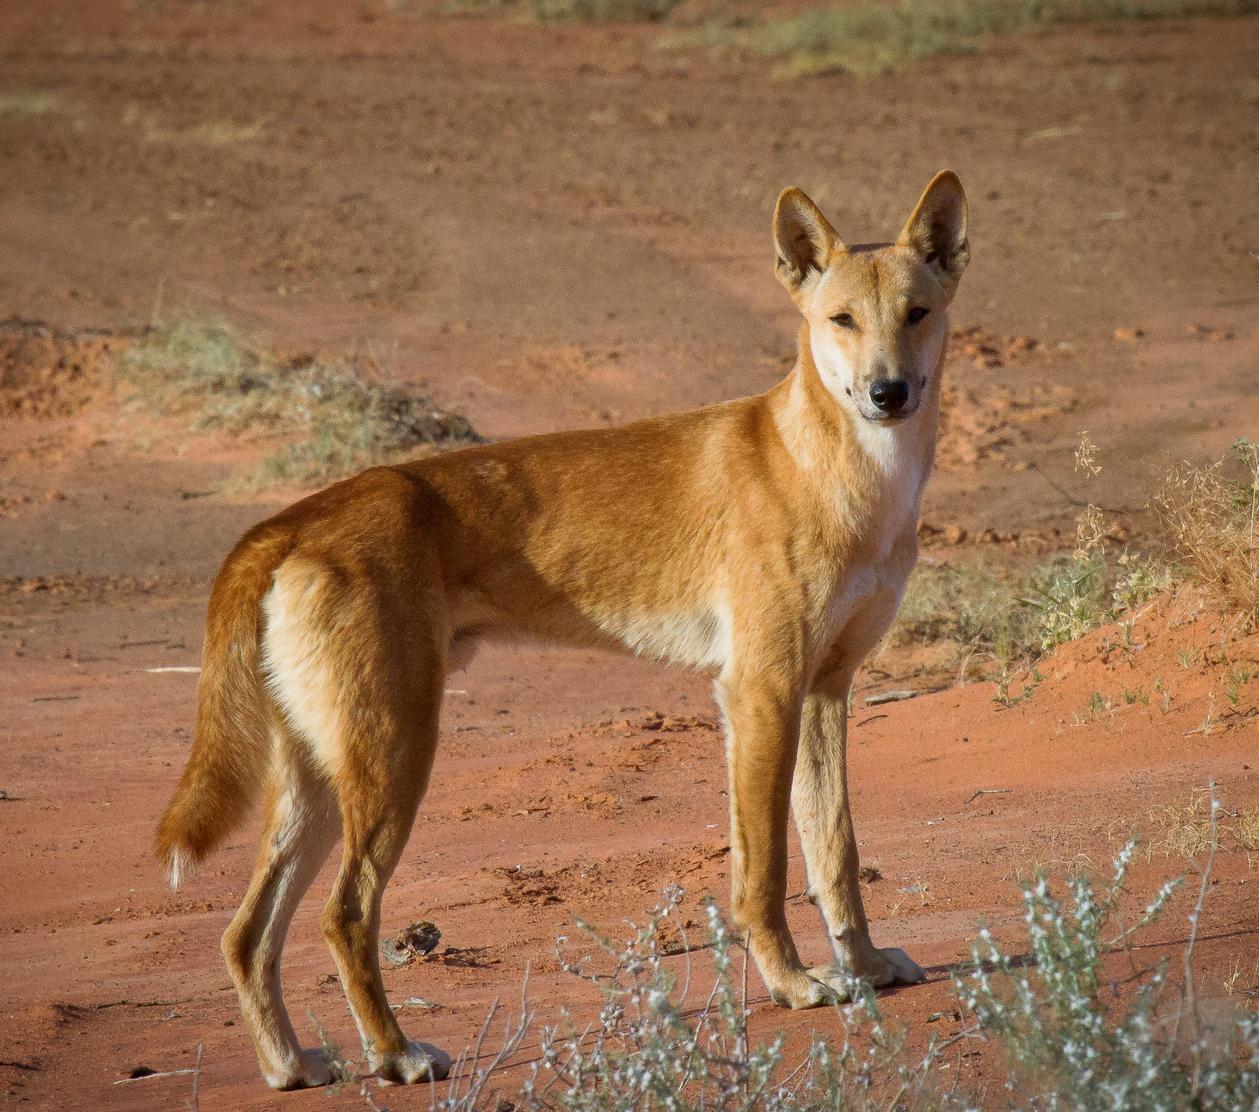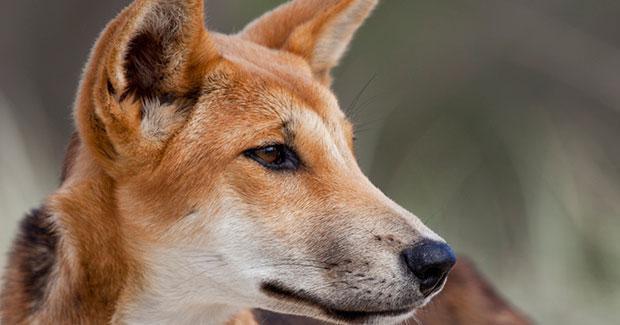The first image is the image on the left, the second image is the image on the right. Analyze the images presented: Is the assertion "A total of two canines are shown." valid? Answer yes or no. Yes. 